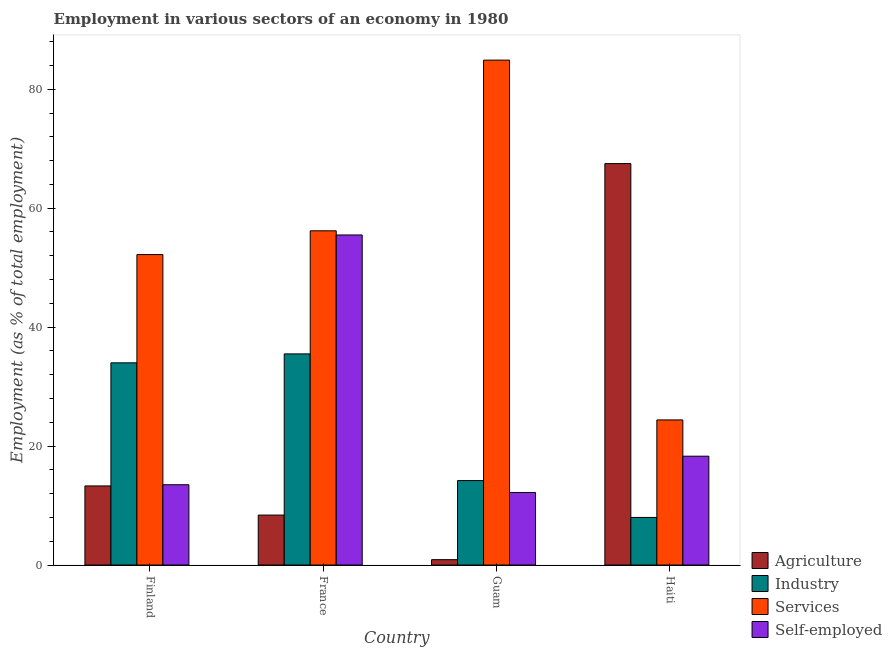How many different coloured bars are there?
Ensure brevity in your answer.  4. Are the number of bars per tick equal to the number of legend labels?
Give a very brief answer. Yes. How many bars are there on the 4th tick from the left?
Offer a very short reply. 4. How many bars are there on the 1st tick from the right?
Provide a succinct answer. 4. What is the percentage of workers in industry in France?
Give a very brief answer. 35.5. Across all countries, what is the maximum percentage of workers in services?
Offer a terse response. 84.9. Across all countries, what is the minimum percentage of self employed workers?
Ensure brevity in your answer.  12.2. In which country was the percentage of workers in services maximum?
Keep it short and to the point. Guam. In which country was the percentage of workers in agriculture minimum?
Offer a very short reply. Guam. What is the total percentage of workers in agriculture in the graph?
Keep it short and to the point. 90.1. What is the difference between the percentage of workers in agriculture in Finland and that in France?
Offer a terse response. 4.9. What is the difference between the percentage of workers in agriculture in Haiti and the percentage of self employed workers in France?
Your answer should be very brief. 12. What is the average percentage of workers in services per country?
Provide a short and direct response. 54.43. What is the difference between the percentage of workers in agriculture and percentage of self employed workers in France?
Offer a very short reply. -47.1. In how many countries, is the percentage of workers in industry greater than 16 %?
Ensure brevity in your answer.  2. What is the ratio of the percentage of workers in agriculture in Guam to that in Haiti?
Offer a terse response. 0.01. Is the difference between the percentage of self employed workers in Finland and France greater than the difference between the percentage of workers in services in Finland and France?
Your response must be concise. No. What is the difference between the highest and the second highest percentage of workers in services?
Offer a very short reply. 28.7. Is the sum of the percentage of workers in services in Guam and Haiti greater than the maximum percentage of workers in agriculture across all countries?
Provide a short and direct response. Yes. Is it the case that in every country, the sum of the percentage of workers in services and percentage of workers in agriculture is greater than the sum of percentage of self employed workers and percentage of workers in industry?
Your response must be concise. No. What does the 1st bar from the left in France represents?
Provide a succinct answer. Agriculture. What does the 2nd bar from the right in Guam represents?
Your answer should be very brief. Services. How many bars are there?
Offer a very short reply. 16. Are all the bars in the graph horizontal?
Your response must be concise. No. How many countries are there in the graph?
Keep it short and to the point. 4. Does the graph contain grids?
Make the answer very short. No. Where does the legend appear in the graph?
Your answer should be compact. Bottom right. What is the title of the graph?
Provide a succinct answer. Employment in various sectors of an economy in 1980. What is the label or title of the Y-axis?
Your response must be concise. Employment (as % of total employment). What is the Employment (as % of total employment) in Agriculture in Finland?
Offer a terse response. 13.3. What is the Employment (as % of total employment) in Industry in Finland?
Make the answer very short. 34. What is the Employment (as % of total employment) of Services in Finland?
Offer a terse response. 52.2. What is the Employment (as % of total employment) in Self-employed in Finland?
Your answer should be very brief. 13.5. What is the Employment (as % of total employment) in Agriculture in France?
Your answer should be compact. 8.4. What is the Employment (as % of total employment) in Industry in France?
Give a very brief answer. 35.5. What is the Employment (as % of total employment) in Services in France?
Ensure brevity in your answer.  56.2. What is the Employment (as % of total employment) of Self-employed in France?
Your answer should be compact. 55.5. What is the Employment (as % of total employment) of Agriculture in Guam?
Provide a short and direct response. 0.9. What is the Employment (as % of total employment) in Industry in Guam?
Your response must be concise. 14.2. What is the Employment (as % of total employment) in Services in Guam?
Provide a short and direct response. 84.9. What is the Employment (as % of total employment) in Self-employed in Guam?
Your answer should be very brief. 12.2. What is the Employment (as % of total employment) in Agriculture in Haiti?
Give a very brief answer. 67.5. What is the Employment (as % of total employment) in Industry in Haiti?
Ensure brevity in your answer.  8. What is the Employment (as % of total employment) in Services in Haiti?
Provide a short and direct response. 24.4. What is the Employment (as % of total employment) of Self-employed in Haiti?
Offer a very short reply. 18.3. Across all countries, what is the maximum Employment (as % of total employment) of Agriculture?
Make the answer very short. 67.5. Across all countries, what is the maximum Employment (as % of total employment) in Industry?
Offer a very short reply. 35.5. Across all countries, what is the maximum Employment (as % of total employment) of Services?
Provide a short and direct response. 84.9. Across all countries, what is the maximum Employment (as % of total employment) in Self-employed?
Give a very brief answer. 55.5. Across all countries, what is the minimum Employment (as % of total employment) in Agriculture?
Offer a terse response. 0.9. Across all countries, what is the minimum Employment (as % of total employment) of Industry?
Keep it short and to the point. 8. Across all countries, what is the minimum Employment (as % of total employment) of Services?
Offer a terse response. 24.4. Across all countries, what is the minimum Employment (as % of total employment) of Self-employed?
Offer a terse response. 12.2. What is the total Employment (as % of total employment) of Agriculture in the graph?
Ensure brevity in your answer.  90.1. What is the total Employment (as % of total employment) in Industry in the graph?
Your answer should be compact. 91.7. What is the total Employment (as % of total employment) in Services in the graph?
Provide a succinct answer. 217.7. What is the total Employment (as % of total employment) in Self-employed in the graph?
Give a very brief answer. 99.5. What is the difference between the Employment (as % of total employment) of Agriculture in Finland and that in France?
Provide a short and direct response. 4.9. What is the difference between the Employment (as % of total employment) in Self-employed in Finland and that in France?
Ensure brevity in your answer.  -42. What is the difference between the Employment (as % of total employment) in Industry in Finland and that in Guam?
Keep it short and to the point. 19.8. What is the difference between the Employment (as % of total employment) of Services in Finland and that in Guam?
Keep it short and to the point. -32.7. What is the difference between the Employment (as % of total employment) in Self-employed in Finland and that in Guam?
Your answer should be compact. 1.3. What is the difference between the Employment (as % of total employment) in Agriculture in Finland and that in Haiti?
Provide a short and direct response. -54.2. What is the difference between the Employment (as % of total employment) in Services in Finland and that in Haiti?
Provide a succinct answer. 27.8. What is the difference between the Employment (as % of total employment) of Self-employed in Finland and that in Haiti?
Give a very brief answer. -4.8. What is the difference between the Employment (as % of total employment) in Agriculture in France and that in Guam?
Give a very brief answer. 7.5. What is the difference between the Employment (as % of total employment) of Industry in France and that in Guam?
Offer a terse response. 21.3. What is the difference between the Employment (as % of total employment) in Services in France and that in Guam?
Offer a terse response. -28.7. What is the difference between the Employment (as % of total employment) of Self-employed in France and that in Guam?
Your response must be concise. 43.3. What is the difference between the Employment (as % of total employment) in Agriculture in France and that in Haiti?
Offer a terse response. -59.1. What is the difference between the Employment (as % of total employment) in Industry in France and that in Haiti?
Your answer should be compact. 27.5. What is the difference between the Employment (as % of total employment) in Services in France and that in Haiti?
Make the answer very short. 31.8. What is the difference between the Employment (as % of total employment) in Self-employed in France and that in Haiti?
Your response must be concise. 37.2. What is the difference between the Employment (as % of total employment) of Agriculture in Guam and that in Haiti?
Your answer should be compact. -66.6. What is the difference between the Employment (as % of total employment) in Industry in Guam and that in Haiti?
Provide a succinct answer. 6.2. What is the difference between the Employment (as % of total employment) in Services in Guam and that in Haiti?
Offer a very short reply. 60.5. What is the difference between the Employment (as % of total employment) of Agriculture in Finland and the Employment (as % of total employment) of Industry in France?
Your answer should be very brief. -22.2. What is the difference between the Employment (as % of total employment) of Agriculture in Finland and the Employment (as % of total employment) of Services in France?
Offer a terse response. -42.9. What is the difference between the Employment (as % of total employment) of Agriculture in Finland and the Employment (as % of total employment) of Self-employed in France?
Provide a succinct answer. -42.2. What is the difference between the Employment (as % of total employment) of Industry in Finland and the Employment (as % of total employment) of Services in France?
Keep it short and to the point. -22.2. What is the difference between the Employment (as % of total employment) of Industry in Finland and the Employment (as % of total employment) of Self-employed in France?
Give a very brief answer. -21.5. What is the difference between the Employment (as % of total employment) in Services in Finland and the Employment (as % of total employment) in Self-employed in France?
Offer a very short reply. -3.3. What is the difference between the Employment (as % of total employment) of Agriculture in Finland and the Employment (as % of total employment) of Services in Guam?
Offer a terse response. -71.6. What is the difference between the Employment (as % of total employment) in Industry in Finland and the Employment (as % of total employment) in Services in Guam?
Provide a short and direct response. -50.9. What is the difference between the Employment (as % of total employment) in Industry in Finland and the Employment (as % of total employment) in Self-employed in Guam?
Provide a short and direct response. 21.8. What is the difference between the Employment (as % of total employment) of Services in Finland and the Employment (as % of total employment) of Self-employed in Guam?
Offer a very short reply. 40. What is the difference between the Employment (as % of total employment) in Agriculture in Finland and the Employment (as % of total employment) in Services in Haiti?
Make the answer very short. -11.1. What is the difference between the Employment (as % of total employment) of Agriculture in Finland and the Employment (as % of total employment) of Self-employed in Haiti?
Your answer should be compact. -5. What is the difference between the Employment (as % of total employment) in Industry in Finland and the Employment (as % of total employment) in Services in Haiti?
Offer a terse response. 9.6. What is the difference between the Employment (as % of total employment) of Industry in Finland and the Employment (as % of total employment) of Self-employed in Haiti?
Offer a very short reply. 15.7. What is the difference between the Employment (as % of total employment) of Services in Finland and the Employment (as % of total employment) of Self-employed in Haiti?
Your answer should be compact. 33.9. What is the difference between the Employment (as % of total employment) of Agriculture in France and the Employment (as % of total employment) of Services in Guam?
Keep it short and to the point. -76.5. What is the difference between the Employment (as % of total employment) of Industry in France and the Employment (as % of total employment) of Services in Guam?
Your answer should be compact. -49.4. What is the difference between the Employment (as % of total employment) of Industry in France and the Employment (as % of total employment) of Self-employed in Guam?
Your answer should be compact. 23.3. What is the difference between the Employment (as % of total employment) of Services in France and the Employment (as % of total employment) of Self-employed in Guam?
Your answer should be compact. 44. What is the difference between the Employment (as % of total employment) in Services in France and the Employment (as % of total employment) in Self-employed in Haiti?
Ensure brevity in your answer.  37.9. What is the difference between the Employment (as % of total employment) in Agriculture in Guam and the Employment (as % of total employment) in Industry in Haiti?
Make the answer very short. -7.1. What is the difference between the Employment (as % of total employment) of Agriculture in Guam and the Employment (as % of total employment) of Services in Haiti?
Your response must be concise. -23.5. What is the difference between the Employment (as % of total employment) of Agriculture in Guam and the Employment (as % of total employment) of Self-employed in Haiti?
Keep it short and to the point. -17.4. What is the difference between the Employment (as % of total employment) in Industry in Guam and the Employment (as % of total employment) in Services in Haiti?
Offer a very short reply. -10.2. What is the difference between the Employment (as % of total employment) in Industry in Guam and the Employment (as % of total employment) in Self-employed in Haiti?
Offer a terse response. -4.1. What is the difference between the Employment (as % of total employment) in Services in Guam and the Employment (as % of total employment) in Self-employed in Haiti?
Offer a terse response. 66.6. What is the average Employment (as % of total employment) in Agriculture per country?
Offer a terse response. 22.52. What is the average Employment (as % of total employment) in Industry per country?
Your answer should be very brief. 22.93. What is the average Employment (as % of total employment) of Services per country?
Ensure brevity in your answer.  54.42. What is the average Employment (as % of total employment) of Self-employed per country?
Provide a succinct answer. 24.88. What is the difference between the Employment (as % of total employment) of Agriculture and Employment (as % of total employment) of Industry in Finland?
Provide a short and direct response. -20.7. What is the difference between the Employment (as % of total employment) in Agriculture and Employment (as % of total employment) in Services in Finland?
Your response must be concise. -38.9. What is the difference between the Employment (as % of total employment) in Agriculture and Employment (as % of total employment) in Self-employed in Finland?
Offer a very short reply. -0.2. What is the difference between the Employment (as % of total employment) of Industry and Employment (as % of total employment) of Services in Finland?
Provide a succinct answer. -18.2. What is the difference between the Employment (as % of total employment) in Industry and Employment (as % of total employment) in Self-employed in Finland?
Your answer should be very brief. 20.5. What is the difference between the Employment (as % of total employment) of Services and Employment (as % of total employment) of Self-employed in Finland?
Ensure brevity in your answer.  38.7. What is the difference between the Employment (as % of total employment) of Agriculture and Employment (as % of total employment) of Industry in France?
Make the answer very short. -27.1. What is the difference between the Employment (as % of total employment) of Agriculture and Employment (as % of total employment) of Services in France?
Offer a very short reply. -47.8. What is the difference between the Employment (as % of total employment) in Agriculture and Employment (as % of total employment) in Self-employed in France?
Give a very brief answer. -47.1. What is the difference between the Employment (as % of total employment) in Industry and Employment (as % of total employment) in Services in France?
Offer a terse response. -20.7. What is the difference between the Employment (as % of total employment) in Services and Employment (as % of total employment) in Self-employed in France?
Provide a short and direct response. 0.7. What is the difference between the Employment (as % of total employment) of Agriculture and Employment (as % of total employment) of Services in Guam?
Give a very brief answer. -84. What is the difference between the Employment (as % of total employment) in Agriculture and Employment (as % of total employment) in Self-employed in Guam?
Your answer should be very brief. -11.3. What is the difference between the Employment (as % of total employment) in Industry and Employment (as % of total employment) in Services in Guam?
Offer a terse response. -70.7. What is the difference between the Employment (as % of total employment) of Industry and Employment (as % of total employment) of Self-employed in Guam?
Give a very brief answer. 2. What is the difference between the Employment (as % of total employment) of Services and Employment (as % of total employment) of Self-employed in Guam?
Offer a terse response. 72.7. What is the difference between the Employment (as % of total employment) in Agriculture and Employment (as % of total employment) in Industry in Haiti?
Your response must be concise. 59.5. What is the difference between the Employment (as % of total employment) in Agriculture and Employment (as % of total employment) in Services in Haiti?
Provide a succinct answer. 43.1. What is the difference between the Employment (as % of total employment) of Agriculture and Employment (as % of total employment) of Self-employed in Haiti?
Provide a succinct answer. 49.2. What is the difference between the Employment (as % of total employment) of Industry and Employment (as % of total employment) of Services in Haiti?
Provide a succinct answer. -16.4. What is the difference between the Employment (as % of total employment) in Industry and Employment (as % of total employment) in Self-employed in Haiti?
Your response must be concise. -10.3. What is the ratio of the Employment (as % of total employment) of Agriculture in Finland to that in France?
Ensure brevity in your answer.  1.58. What is the ratio of the Employment (as % of total employment) in Industry in Finland to that in France?
Give a very brief answer. 0.96. What is the ratio of the Employment (as % of total employment) of Services in Finland to that in France?
Ensure brevity in your answer.  0.93. What is the ratio of the Employment (as % of total employment) in Self-employed in Finland to that in France?
Your answer should be very brief. 0.24. What is the ratio of the Employment (as % of total employment) in Agriculture in Finland to that in Guam?
Offer a very short reply. 14.78. What is the ratio of the Employment (as % of total employment) in Industry in Finland to that in Guam?
Keep it short and to the point. 2.39. What is the ratio of the Employment (as % of total employment) in Services in Finland to that in Guam?
Make the answer very short. 0.61. What is the ratio of the Employment (as % of total employment) of Self-employed in Finland to that in Guam?
Ensure brevity in your answer.  1.11. What is the ratio of the Employment (as % of total employment) of Agriculture in Finland to that in Haiti?
Offer a very short reply. 0.2. What is the ratio of the Employment (as % of total employment) in Industry in Finland to that in Haiti?
Offer a terse response. 4.25. What is the ratio of the Employment (as % of total employment) in Services in Finland to that in Haiti?
Provide a succinct answer. 2.14. What is the ratio of the Employment (as % of total employment) of Self-employed in Finland to that in Haiti?
Your response must be concise. 0.74. What is the ratio of the Employment (as % of total employment) in Agriculture in France to that in Guam?
Your answer should be compact. 9.33. What is the ratio of the Employment (as % of total employment) in Services in France to that in Guam?
Give a very brief answer. 0.66. What is the ratio of the Employment (as % of total employment) in Self-employed in France to that in Guam?
Your response must be concise. 4.55. What is the ratio of the Employment (as % of total employment) in Agriculture in France to that in Haiti?
Provide a succinct answer. 0.12. What is the ratio of the Employment (as % of total employment) in Industry in France to that in Haiti?
Offer a very short reply. 4.44. What is the ratio of the Employment (as % of total employment) in Services in France to that in Haiti?
Your answer should be very brief. 2.3. What is the ratio of the Employment (as % of total employment) of Self-employed in France to that in Haiti?
Offer a very short reply. 3.03. What is the ratio of the Employment (as % of total employment) of Agriculture in Guam to that in Haiti?
Make the answer very short. 0.01. What is the ratio of the Employment (as % of total employment) of Industry in Guam to that in Haiti?
Offer a very short reply. 1.77. What is the ratio of the Employment (as % of total employment) in Services in Guam to that in Haiti?
Offer a terse response. 3.48. What is the ratio of the Employment (as % of total employment) in Self-employed in Guam to that in Haiti?
Give a very brief answer. 0.67. What is the difference between the highest and the second highest Employment (as % of total employment) of Agriculture?
Provide a short and direct response. 54.2. What is the difference between the highest and the second highest Employment (as % of total employment) of Industry?
Ensure brevity in your answer.  1.5. What is the difference between the highest and the second highest Employment (as % of total employment) in Services?
Ensure brevity in your answer.  28.7. What is the difference between the highest and the second highest Employment (as % of total employment) of Self-employed?
Your response must be concise. 37.2. What is the difference between the highest and the lowest Employment (as % of total employment) of Agriculture?
Make the answer very short. 66.6. What is the difference between the highest and the lowest Employment (as % of total employment) in Industry?
Offer a terse response. 27.5. What is the difference between the highest and the lowest Employment (as % of total employment) in Services?
Provide a succinct answer. 60.5. What is the difference between the highest and the lowest Employment (as % of total employment) of Self-employed?
Ensure brevity in your answer.  43.3. 